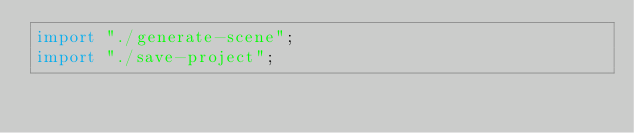Convert code to text. <code><loc_0><loc_0><loc_500><loc_500><_TypeScript_>import "./generate-scene";
import "./save-project";
</code> 